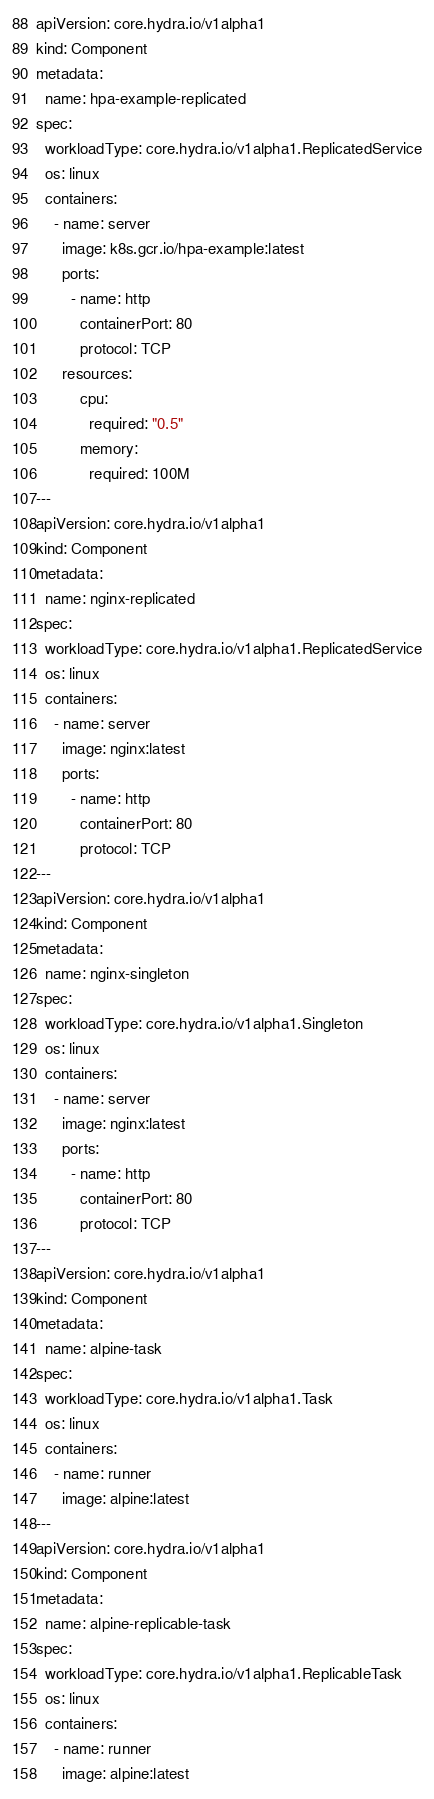Convert code to text. <code><loc_0><loc_0><loc_500><loc_500><_YAML_>apiVersion: core.hydra.io/v1alpha1
kind: Component
metadata:
  name: hpa-example-replicated
spec:
  workloadType: core.hydra.io/v1alpha1.ReplicatedService
  os: linux
  containers:
    - name: server
      image: k8s.gcr.io/hpa-example:latest
      ports:
        - name: http
          containerPort: 80
          protocol: TCP
      resources:
          cpu:
            required: "0.5"
          memory:
            required: 100M
---
apiVersion: core.hydra.io/v1alpha1
kind: Component
metadata:
  name: nginx-replicated
spec:
  workloadType: core.hydra.io/v1alpha1.ReplicatedService
  os: linux
  containers:
    - name: server
      image: nginx:latest
      ports:
        - name: http
          containerPort: 80
          protocol: TCP
---
apiVersion: core.hydra.io/v1alpha1
kind: Component
metadata:
  name: nginx-singleton
spec:
  workloadType: core.hydra.io/v1alpha1.Singleton
  os: linux
  containers:
    - name: server
      image: nginx:latest
      ports:
        - name: http
          containerPort: 80
          protocol: TCP
---
apiVersion: core.hydra.io/v1alpha1
kind: Component
metadata:
  name: alpine-task
spec:
  workloadType: core.hydra.io/v1alpha1.Task
  os: linux
  containers:
    - name: runner
      image: alpine:latest
---
apiVersion: core.hydra.io/v1alpha1
kind: Component
metadata:
  name: alpine-replicable-task
spec:
  workloadType: core.hydra.io/v1alpha1.ReplicableTask
  os: linux
  containers:
    - name: runner
      image: alpine:latest</code> 